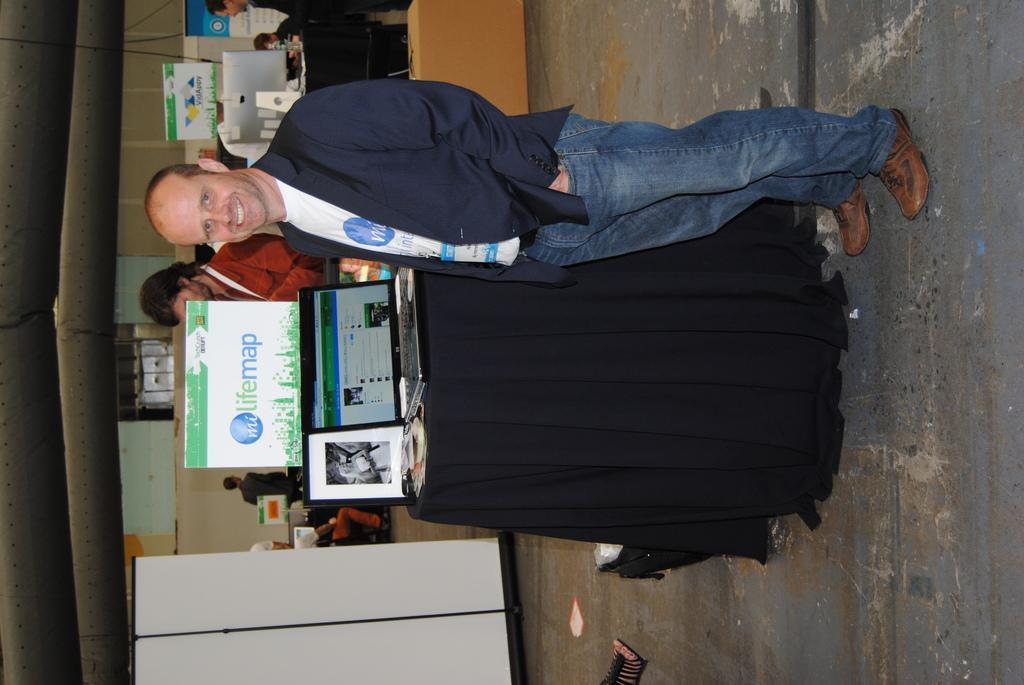How would you summarize this image in a sentence or two? In the middle of the image we can see a table covered with cloth and laptop, photograph on it. Beside the table we can see a man standing on the floor. In the background we can see advertisements, walls, tables and persons sitting. 